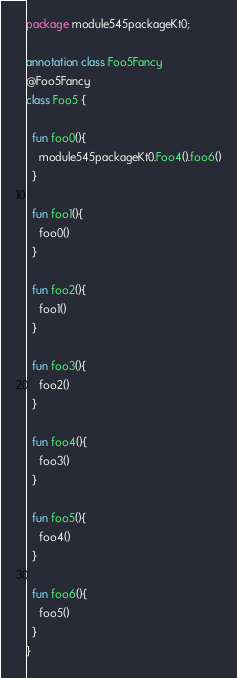Convert code to text. <code><loc_0><loc_0><loc_500><loc_500><_Kotlin_>package module545packageKt0;

annotation class Foo5Fancy
@Foo5Fancy
class Foo5 {

  fun foo0(){
    module545packageKt0.Foo4().foo6()
  }

  fun foo1(){
    foo0()
  }

  fun foo2(){
    foo1()
  }

  fun foo3(){
    foo2()
  }

  fun foo4(){
    foo3()
  }

  fun foo5(){
    foo4()
  }

  fun foo6(){
    foo5()
  }
}</code> 